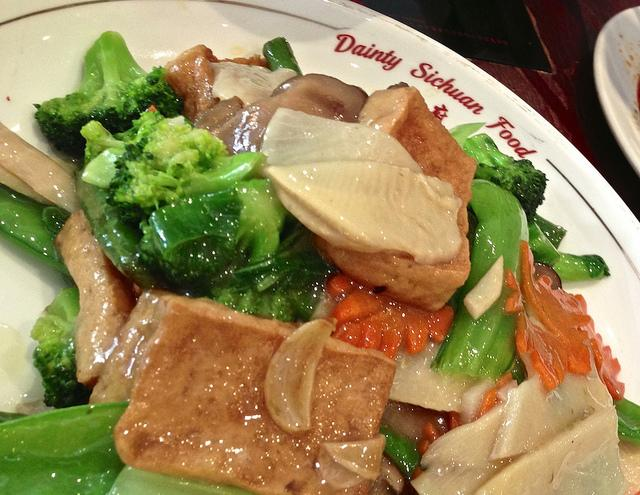What kind of cuisine is being served?

Choices:
A) chinese
B) korean
C) indian
D) japanese chinese 